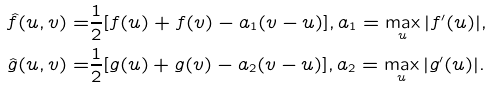Convert formula to latex. <formula><loc_0><loc_0><loc_500><loc_500>\hat { f } ( u , v ) = & \frac { 1 } { 2 } [ f ( u ) + f ( v ) - a _ { 1 } ( v - u ) ] , a _ { 1 } = \max _ { u } | f ^ { \prime } ( u ) | , \\ \hat { g } ( u , v ) = & \frac { 1 } { 2 } [ g ( u ) + g ( v ) - a _ { 2 } ( v - u ) ] , a _ { 2 } = \max _ { u } | g ^ { \prime } ( u ) | .</formula> 